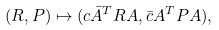Convert formula to latex. <formula><loc_0><loc_0><loc_500><loc_500>( R , P ) \mapsto ( c \bar { A } ^ { T } R A , \bar { c } A ^ { T } P A ) ,</formula> 